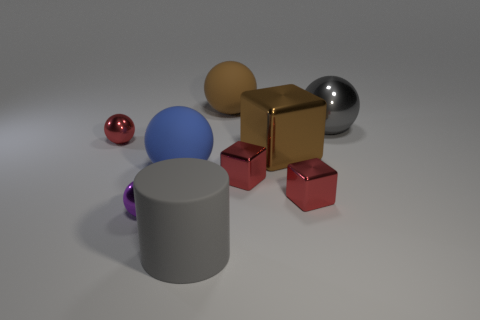What time of day or setting does this lighting remind you of? The lighting used in the scene is reminiscent of an overcast day or an indoor setting with soft, artificial lights. There's no harsh sunlight or strong directional shadows, which would be indicative of a different time of day or lighting setup. 